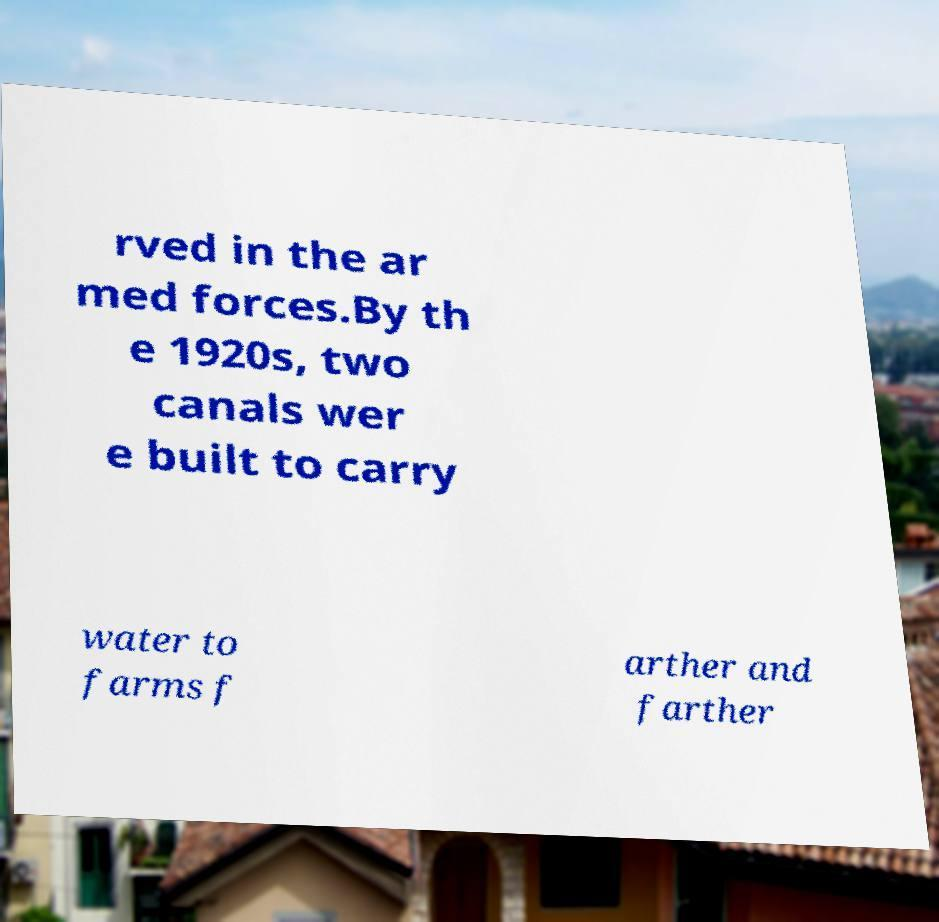Can you read and provide the text displayed in the image?This photo seems to have some interesting text. Can you extract and type it out for me? rved in the ar med forces.By th e 1920s, two canals wer e built to carry water to farms f arther and farther 